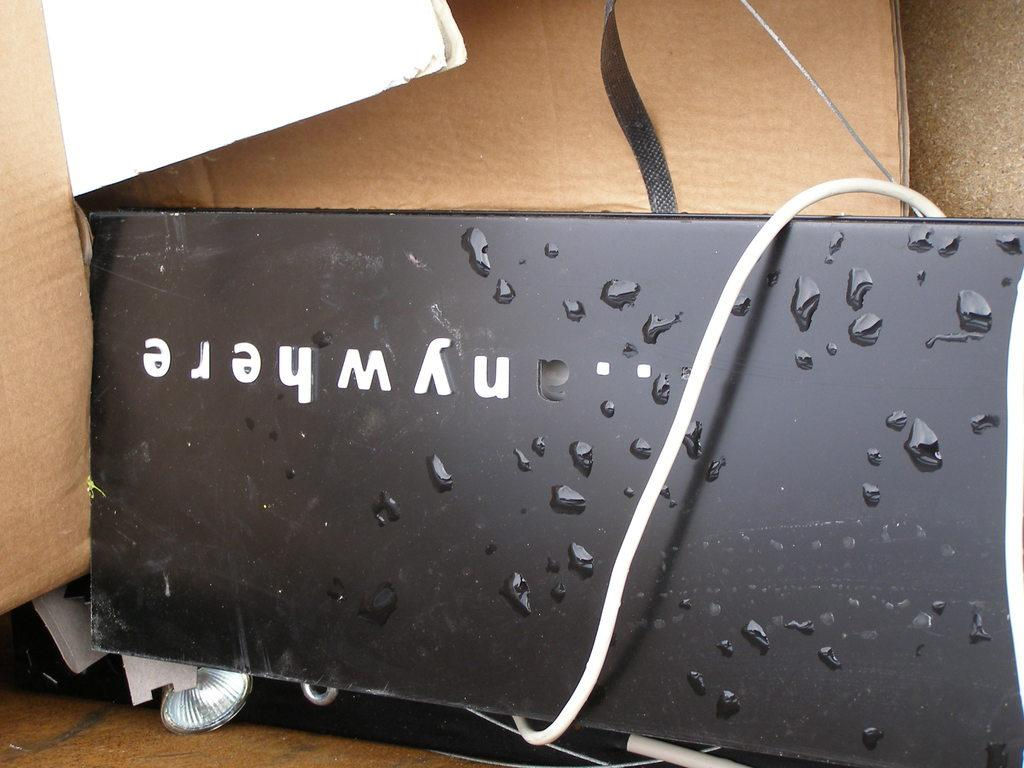Provide a one-sentence caption for the provided image. A black phone that is upside down and has the letters nywhere on it. 